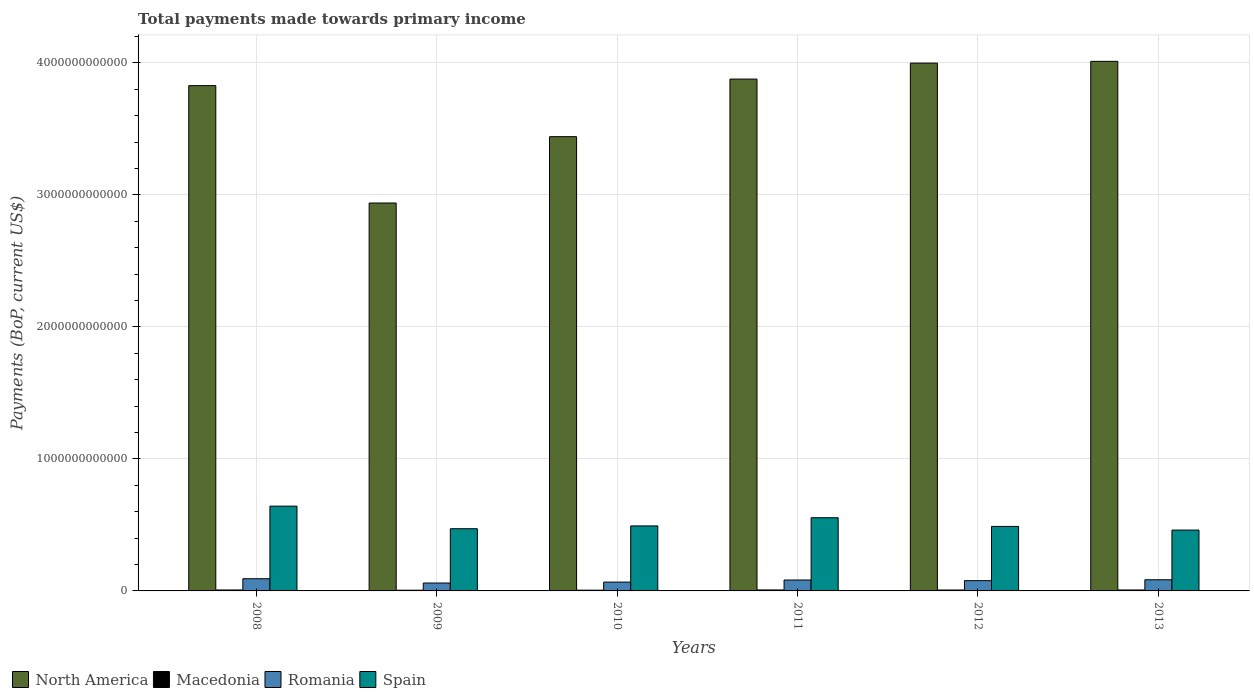How many different coloured bars are there?
Your answer should be very brief. 4. Are the number of bars per tick equal to the number of legend labels?
Offer a terse response. Yes. What is the label of the 3rd group of bars from the left?
Offer a terse response. 2010. In how many cases, is the number of bars for a given year not equal to the number of legend labels?
Make the answer very short. 0. What is the total payments made towards primary income in Spain in 2012?
Ensure brevity in your answer.  4.89e+11. Across all years, what is the maximum total payments made towards primary income in Spain?
Provide a short and direct response. 6.42e+11. Across all years, what is the minimum total payments made towards primary income in Macedonia?
Offer a very short reply. 5.38e+09. In which year was the total payments made towards primary income in Romania maximum?
Provide a succinct answer. 2008. In which year was the total payments made towards primary income in North America minimum?
Give a very brief answer. 2009. What is the total total payments made towards primary income in Romania in the graph?
Provide a short and direct response. 4.64e+11. What is the difference between the total payments made towards primary income in North America in 2009 and that in 2010?
Make the answer very short. -5.02e+11. What is the difference between the total payments made towards primary income in Macedonia in 2011 and the total payments made towards primary income in Spain in 2013?
Your answer should be compact. -4.54e+11. What is the average total payments made towards primary income in North America per year?
Provide a succinct answer. 3.68e+12. In the year 2013, what is the difference between the total payments made towards primary income in Spain and total payments made towards primary income in Romania?
Provide a succinct answer. 3.76e+11. What is the ratio of the total payments made towards primary income in North America in 2008 to that in 2009?
Your answer should be very brief. 1.3. What is the difference between the highest and the second highest total payments made towards primary income in Romania?
Your response must be concise. 7.71e+09. What is the difference between the highest and the lowest total payments made towards primary income in Macedonia?
Provide a short and direct response. 1.97e+09. Is the sum of the total payments made towards primary income in Spain in 2009 and 2013 greater than the maximum total payments made towards primary income in Macedonia across all years?
Offer a terse response. Yes. Is it the case that in every year, the sum of the total payments made towards primary income in Macedonia and total payments made towards primary income in Romania is greater than the sum of total payments made towards primary income in Spain and total payments made towards primary income in North America?
Provide a succinct answer. No. What does the 3rd bar from the left in 2010 represents?
Offer a very short reply. Romania. What does the 3rd bar from the right in 2010 represents?
Provide a succinct answer. Macedonia. Is it the case that in every year, the sum of the total payments made towards primary income in Macedonia and total payments made towards primary income in North America is greater than the total payments made towards primary income in Spain?
Provide a short and direct response. Yes. Are all the bars in the graph horizontal?
Give a very brief answer. No. How many years are there in the graph?
Offer a terse response. 6. What is the difference between two consecutive major ticks on the Y-axis?
Your answer should be very brief. 1.00e+12. Are the values on the major ticks of Y-axis written in scientific E-notation?
Give a very brief answer. No. Does the graph contain grids?
Your response must be concise. Yes. Where does the legend appear in the graph?
Ensure brevity in your answer.  Bottom left. What is the title of the graph?
Your response must be concise. Total payments made towards primary income. What is the label or title of the Y-axis?
Keep it short and to the point. Payments (BoP, current US$). What is the Payments (BoP, current US$) in North America in 2008?
Provide a short and direct response. 3.83e+12. What is the Payments (BoP, current US$) of Macedonia in 2008?
Keep it short and to the point. 7.21e+09. What is the Payments (BoP, current US$) in Romania in 2008?
Your answer should be compact. 9.23e+1. What is the Payments (BoP, current US$) in Spain in 2008?
Give a very brief answer. 6.42e+11. What is the Payments (BoP, current US$) in North America in 2009?
Make the answer very short. 2.94e+12. What is the Payments (BoP, current US$) in Macedonia in 2009?
Offer a terse response. 5.38e+09. What is the Payments (BoP, current US$) in Romania in 2009?
Offer a very short reply. 5.98e+1. What is the Payments (BoP, current US$) in Spain in 2009?
Give a very brief answer. 4.71e+11. What is the Payments (BoP, current US$) in North America in 2010?
Make the answer very short. 3.44e+12. What is the Payments (BoP, current US$) in Macedonia in 2010?
Offer a terse response. 5.79e+09. What is the Payments (BoP, current US$) in Romania in 2010?
Ensure brevity in your answer.  6.70e+1. What is the Payments (BoP, current US$) of Spain in 2010?
Your answer should be very brief. 4.93e+11. What is the Payments (BoP, current US$) in North America in 2011?
Ensure brevity in your answer.  3.88e+12. What is the Payments (BoP, current US$) of Macedonia in 2011?
Your answer should be very brief. 7.35e+09. What is the Payments (BoP, current US$) in Romania in 2011?
Make the answer very short. 8.27e+1. What is the Payments (BoP, current US$) in Spain in 2011?
Give a very brief answer. 5.54e+11. What is the Payments (BoP, current US$) of North America in 2012?
Give a very brief answer. 4.00e+12. What is the Payments (BoP, current US$) in Macedonia in 2012?
Provide a short and direct response. 6.92e+09. What is the Payments (BoP, current US$) of Romania in 2012?
Provide a succinct answer. 7.77e+1. What is the Payments (BoP, current US$) in Spain in 2012?
Your answer should be very brief. 4.89e+11. What is the Payments (BoP, current US$) in North America in 2013?
Provide a succinct answer. 4.01e+12. What is the Payments (BoP, current US$) of Macedonia in 2013?
Provide a short and direct response. 7.11e+09. What is the Payments (BoP, current US$) in Romania in 2013?
Provide a short and direct response. 8.46e+1. What is the Payments (BoP, current US$) of Spain in 2013?
Your answer should be very brief. 4.61e+11. Across all years, what is the maximum Payments (BoP, current US$) in North America?
Provide a succinct answer. 4.01e+12. Across all years, what is the maximum Payments (BoP, current US$) in Macedonia?
Make the answer very short. 7.35e+09. Across all years, what is the maximum Payments (BoP, current US$) of Romania?
Make the answer very short. 9.23e+1. Across all years, what is the maximum Payments (BoP, current US$) in Spain?
Provide a succinct answer. 6.42e+11. Across all years, what is the minimum Payments (BoP, current US$) of North America?
Your response must be concise. 2.94e+12. Across all years, what is the minimum Payments (BoP, current US$) in Macedonia?
Ensure brevity in your answer.  5.38e+09. Across all years, what is the minimum Payments (BoP, current US$) in Romania?
Your response must be concise. 5.98e+1. Across all years, what is the minimum Payments (BoP, current US$) of Spain?
Give a very brief answer. 4.61e+11. What is the total Payments (BoP, current US$) in North America in the graph?
Offer a very short reply. 2.21e+13. What is the total Payments (BoP, current US$) in Macedonia in the graph?
Offer a very short reply. 3.97e+1. What is the total Payments (BoP, current US$) in Romania in the graph?
Ensure brevity in your answer.  4.64e+11. What is the total Payments (BoP, current US$) in Spain in the graph?
Provide a succinct answer. 3.11e+12. What is the difference between the Payments (BoP, current US$) in North America in 2008 and that in 2009?
Keep it short and to the point. 8.89e+11. What is the difference between the Payments (BoP, current US$) in Macedonia in 2008 and that in 2009?
Give a very brief answer. 1.83e+09. What is the difference between the Payments (BoP, current US$) of Romania in 2008 and that in 2009?
Offer a very short reply. 3.25e+1. What is the difference between the Payments (BoP, current US$) of Spain in 2008 and that in 2009?
Offer a very short reply. 1.71e+11. What is the difference between the Payments (BoP, current US$) of North America in 2008 and that in 2010?
Ensure brevity in your answer.  3.87e+11. What is the difference between the Payments (BoP, current US$) in Macedonia in 2008 and that in 2010?
Keep it short and to the point. 1.42e+09. What is the difference between the Payments (BoP, current US$) of Romania in 2008 and that in 2010?
Offer a terse response. 2.54e+1. What is the difference between the Payments (BoP, current US$) of Spain in 2008 and that in 2010?
Ensure brevity in your answer.  1.50e+11. What is the difference between the Payments (BoP, current US$) in North America in 2008 and that in 2011?
Ensure brevity in your answer.  -4.97e+1. What is the difference between the Payments (BoP, current US$) in Macedonia in 2008 and that in 2011?
Your response must be concise. -1.41e+08. What is the difference between the Payments (BoP, current US$) of Romania in 2008 and that in 2011?
Your response must be concise. 9.68e+09. What is the difference between the Payments (BoP, current US$) in Spain in 2008 and that in 2011?
Provide a short and direct response. 8.79e+1. What is the difference between the Payments (BoP, current US$) in North America in 2008 and that in 2012?
Offer a very short reply. -1.71e+11. What is the difference between the Payments (BoP, current US$) of Macedonia in 2008 and that in 2012?
Offer a terse response. 2.89e+08. What is the difference between the Payments (BoP, current US$) in Romania in 2008 and that in 2012?
Give a very brief answer. 1.47e+1. What is the difference between the Payments (BoP, current US$) of Spain in 2008 and that in 2012?
Your response must be concise. 1.54e+11. What is the difference between the Payments (BoP, current US$) of North America in 2008 and that in 2013?
Your answer should be compact. -1.84e+11. What is the difference between the Payments (BoP, current US$) of Macedonia in 2008 and that in 2013?
Offer a terse response. 9.44e+07. What is the difference between the Payments (BoP, current US$) in Romania in 2008 and that in 2013?
Keep it short and to the point. 7.71e+09. What is the difference between the Payments (BoP, current US$) of Spain in 2008 and that in 2013?
Offer a very short reply. 1.81e+11. What is the difference between the Payments (BoP, current US$) in North America in 2009 and that in 2010?
Ensure brevity in your answer.  -5.02e+11. What is the difference between the Payments (BoP, current US$) in Macedonia in 2009 and that in 2010?
Make the answer very short. -4.10e+08. What is the difference between the Payments (BoP, current US$) of Romania in 2009 and that in 2010?
Provide a succinct answer. -7.15e+09. What is the difference between the Payments (BoP, current US$) of Spain in 2009 and that in 2010?
Offer a very short reply. -2.13e+1. What is the difference between the Payments (BoP, current US$) of North America in 2009 and that in 2011?
Keep it short and to the point. -9.39e+11. What is the difference between the Payments (BoP, current US$) of Macedonia in 2009 and that in 2011?
Your response must be concise. -1.97e+09. What is the difference between the Payments (BoP, current US$) of Romania in 2009 and that in 2011?
Your answer should be compact. -2.29e+1. What is the difference between the Payments (BoP, current US$) in Spain in 2009 and that in 2011?
Your answer should be very brief. -8.31e+1. What is the difference between the Payments (BoP, current US$) of North America in 2009 and that in 2012?
Your response must be concise. -1.06e+12. What is the difference between the Payments (BoP, current US$) of Macedonia in 2009 and that in 2012?
Give a very brief answer. -1.54e+09. What is the difference between the Payments (BoP, current US$) of Romania in 2009 and that in 2012?
Ensure brevity in your answer.  -1.79e+1. What is the difference between the Payments (BoP, current US$) of Spain in 2009 and that in 2012?
Offer a very short reply. -1.75e+1. What is the difference between the Payments (BoP, current US$) in North America in 2009 and that in 2013?
Your answer should be compact. -1.07e+12. What is the difference between the Payments (BoP, current US$) of Macedonia in 2009 and that in 2013?
Offer a very short reply. -1.73e+09. What is the difference between the Payments (BoP, current US$) in Romania in 2009 and that in 2013?
Provide a succinct answer. -2.48e+1. What is the difference between the Payments (BoP, current US$) of Spain in 2009 and that in 2013?
Offer a very short reply. 1.04e+1. What is the difference between the Payments (BoP, current US$) of North America in 2010 and that in 2011?
Offer a terse response. -4.37e+11. What is the difference between the Payments (BoP, current US$) of Macedonia in 2010 and that in 2011?
Your answer should be very brief. -1.56e+09. What is the difference between the Payments (BoP, current US$) in Romania in 2010 and that in 2011?
Your response must be concise. -1.57e+1. What is the difference between the Payments (BoP, current US$) in Spain in 2010 and that in 2011?
Keep it short and to the point. -6.18e+1. What is the difference between the Payments (BoP, current US$) in North America in 2010 and that in 2012?
Ensure brevity in your answer.  -5.57e+11. What is the difference between the Payments (BoP, current US$) in Macedonia in 2010 and that in 2012?
Provide a succinct answer. -1.13e+09. What is the difference between the Payments (BoP, current US$) of Romania in 2010 and that in 2012?
Your answer should be compact. -1.07e+1. What is the difference between the Payments (BoP, current US$) in Spain in 2010 and that in 2012?
Your response must be concise. 3.82e+09. What is the difference between the Payments (BoP, current US$) of North America in 2010 and that in 2013?
Provide a succinct answer. -5.71e+11. What is the difference between the Payments (BoP, current US$) of Macedonia in 2010 and that in 2013?
Make the answer very short. -1.32e+09. What is the difference between the Payments (BoP, current US$) of Romania in 2010 and that in 2013?
Provide a succinct answer. -1.77e+1. What is the difference between the Payments (BoP, current US$) in Spain in 2010 and that in 2013?
Your answer should be compact. 3.17e+1. What is the difference between the Payments (BoP, current US$) of North America in 2011 and that in 2012?
Offer a terse response. -1.21e+11. What is the difference between the Payments (BoP, current US$) in Macedonia in 2011 and that in 2012?
Offer a very short reply. 4.29e+08. What is the difference between the Payments (BoP, current US$) in Romania in 2011 and that in 2012?
Offer a very short reply. 4.99e+09. What is the difference between the Payments (BoP, current US$) in Spain in 2011 and that in 2012?
Your answer should be compact. 6.56e+1. What is the difference between the Payments (BoP, current US$) of North America in 2011 and that in 2013?
Offer a terse response. -1.34e+11. What is the difference between the Payments (BoP, current US$) in Macedonia in 2011 and that in 2013?
Give a very brief answer. 2.35e+08. What is the difference between the Payments (BoP, current US$) of Romania in 2011 and that in 2013?
Offer a terse response. -1.97e+09. What is the difference between the Payments (BoP, current US$) of Spain in 2011 and that in 2013?
Give a very brief answer. 9.35e+1. What is the difference between the Payments (BoP, current US$) of North America in 2012 and that in 2013?
Provide a succinct answer. -1.33e+1. What is the difference between the Payments (BoP, current US$) in Macedonia in 2012 and that in 2013?
Keep it short and to the point. -1.94e+08. What is the difference between the Payments (BoP, current US$) of Romania in 2012 and that in 2013?
Provide a succinct answer. -6.96e+09. What is the difference between the Payments (BoP, current US$) of Spain in 2012 and that in 2013?
Keep it short and to the point. 2.79e+1. What is the difference between the Payments (BoP, current US$) of North America in 2008 and the Payments (BoP, current US$) of Macedonia in 2009?
Provide a succinct answer. 3.82e+12. What is the difference between the Payments (BoP, current US$) of North America in 2008 and the Payments (BoP, current US$) of Romania in 2009?
Offer a very short reply. 3.77e+12. What is the difference between the Payments (BoP, current US$) of North America in 2008 and the Payments (BoP, current US$) of Spain in 2009?
Keep it short and to the point. 3.36e+12. What is the difference between the Payments (BoP, current US$) of Macedonia in 2008 and the Payments (BoP, current US$) of Romania in 2009?
Give a very brief answer. -5.26e+1. What is the difference between the Payments (BoP, current US$) in Macedonia in 2008 and the Payments (BoP, current US$) in Spain in 2009?
Offer a very short reply. -4.64e+11. What is the difference between the Payments (BoP, current US$) in Romania in 2008 and the Payments (BoP, current US$) in Spain in 2009?
Your answer should be very brief. -3.79e+11. What is the difference between the Payments (BoP, current US$) in North America in 2008 and the Payments (BoP, current US$) in Macedonia in 2010?
Provide a short and direct response. 3.82e+12. What is the difference between the Payments (BoP, current US$) in North America in 2008 and the Payments (BoP, current US$) in Romania in 2010?
Your answer should be very brief. 3.76e+12. What is the difference between the Payments (BoP, current US$) of North America in 2008 and the Payments (BoP, current US$) of Spain in 2010?
Offer a terse response. 3.34e+12. What is the difference between the Payments (BoP, current US$) in Macedonia in 2008 and the Payments (BoP, current US$) in Romania in 2010?
Make the answer very short. -5.98e+1. What is the difference between the Payments (BoP, current US$) of Macedonia in 2008 and the Payments (BoP, current US$) of Spain in 2010?
Keep it short and to the point. -4.85e+11. What is the difference between the Payments (BoP, current US$) of Romania in 2008 and the Payments (BoP, current US$) of Spain in 2010?
Your answer should be very brief. -4.00e+11. What is the difference between the Payments (BoP, current US$) of North America in 2008 and the Payments (BoP, current US$) of Macedonia in 2011?
Provide a short and direct response. 3.82e+12. What is the difference between the Payments (BoP, current US$) of North America in 2008 and the Payments (BoP, current US$) of Romania in 2011?
Make the answer very short. 3.75e+12. What is the difference between the Payments (BoP, current US$) of North America in 2008 and the Payments (BoP, current US$) of Spain in 2011?
Make the answer very short. 3.27e+12. What is the difference between the Payments (BoP, current US$) of Macedonia in 2008 and the Payments (BoP, current US$) of Romania in 2011?
Ensure brevity in your answer.  -7.55e+1. What is the difference between the Payments (BoP, current US$) of Macedonia in 2008 and the Payments (BoP, current US$) of Spain in 2011?
Make the answer very short. -5.47e+11. What is the difference between the Payments (BoP, current US$) in Romania in 2008 and the Payments (BoP, current US$) in Spain in 2011?
Make the answer very short. -4.62e+11. What is the difference between the Payments (BoP, current US$) of North America in 2008 and the Payments (BoP, current US$) of Macedonia in 2012?
Offer a terse response. 3.82e+12. What is the difference between the Payments (BoP, current US$) in North America in 2008 and the Payments (BoP, current US$) in Romania in 2012?
Your answer should be very brief. 3.75e+12. What is the difference between the Payments (BoP, current US$) of North America in 2008 and the Payments (BoP, current US$) of Spain in 2012?
Keep it short and to the point. 3.34e+12. What is the difference between the Payments (BoP, current US$) in Macedonia in 2008 and the Payments (BoP, current US$) in Romania in 2012?
Your answer should be compact. -7.05e+1. What is the difference between the Payments (BoP, current US$) in Macedonia in 2008 and the Payments (BoP, current US$) in Spain in 2012?
Give a very brief answer. -4.82e+11. What is the difference between the Payments (BoP, current US$) in Romania in 2008 and the Payments (BoP, current US$) in Spain in 2012?
Offer a very short reply. -3.96e+11. What is the difference between the Payments (BoP, current US$) of North America in 2008 and the Payments (BoP, current US$) of Macedonia in 2013?
Provide a short and direct response. 3.82e+12. What is the difference between the Payments (BoP, current US$) of North America in 2008 and the Payments (BoP, current US$) of Romania in 2013?
Provide a succinct answer. 3.74e+12. What is the difference between the Payments (BoP, current US$) in North America in 2008 and the Payments (BoP, current US$) in Spain in 2013?
Provide a succinct answer. 3.37e+12. What is the difference between the Payments (BoP, current US$) in Macedonia in 2008 and the Payments (BoP, current US$) in Romania in 2013?
Keep it short and to the point. -7.74e+1. What is the difference between the Payments (BoP, current US$) in Macedonia in 2008 and the Payments (BoP, current US$) in Spain in 2013?
Make the answer very short. -4.54e+11. What is the difference between the Payments (BoP, current US$) of Romania in 2008 and the Payments (BoP, current US$) of Spain in 2013?
Offer a terse response. -3.69e+11. What is the difference between the Payments (BoP, current US$) in North America in 2009 and the Payments (BoP, current US$) in Macedonia in 2010?
Make the answer very short. 2.93e+12. What is the difference between the Payments (BoP, current US$) in North America in 2009 and the Payments (BoP, current US$) in Romania in 2010?
Your answer should be very brief. 2.87e+12. What is the difference between the Payments (BoP, current US$) in North America in 2009 and the Payments (BoP, current US$) in Spain in 2010?
Your response must be concise. 2.45e+12. What is the difference between the Payments (BoP, current US$) in Macedonia in 2009 and the Payments (BoP, current US$) in Romania in 2010?
Keep it short and to the point. -6.16e+1. What is the difference between the Payments (BoP, current US$) of Macedonia in 2009 and the Payments (BoP, current US$) of Spain in 2010?
Your response must be concise. -4.87e+11. What is the difference between the Payments (BoP, current US$) of Romania in 2009 and the Payments (BoP, current US$) of Spain in 2010?
Ensure brevity in your answer.  -4.33e+11. What is the difference between the Payments (BoP, current US$) in North America in 2009 and the Payments (BoP, current US$) in Macedonia in 2011?
Ensure brevity in your answer.  2.93e+12. What is the difference between the Payments (BoP, current US$) in North America in 2009 and the Payments (BoP, current US$) in Romania in 2011?
Ensure brevity in your answer.  2.86e+12. What is the difference between the Payments (BoP, current US$) in North America in 2009 and the Payments (BoP, current US$) in Spain in 2011?
Your answer should be compact. 2.38e+12. What is the difference between the Payments (BoP, current US$) in Macedonia in 2009 and the Payments (BoP, current US$) in Romania in 2011?
Make the answer very short. -7.73e+1. What is the difference between the Payments (BoP, current US$) in Macedonia in 2009 and the Payments (BoP, current US$) in Spain in 2011?
Make the answer very short. -5.49e+11. What is the difference between the Payments (BoP, current US$) of Romania in 2009 and the Payments (BoP, current US$) of Spain in 2011?
Give a very brief answer. -4.95e+11. What is the difference between the Payments (BoP, current US$) of North America in 2009 and the Payments (BoP, current US$) of Macedonia in 2012?
Provide a short and direct response. 2.93e+12. What is the difference between the Payments (BoP, current US$) in North America in 2009 and the Payments (BoP, current US$) in Romania in 2012?
Ensure brevity in your answer.  2.86e+12. What is the difference between the Payments (BoP, current US$) of North America in 2009 and the Payments (BoP, current US$) of Spain in 2012?
Your response must be concise. 2.45e+12. What is the difference between the Payments (BoP, current US$) of Macedonia in 2009 and the Payments (BoP, current US$) of Romania in 2012?
Your response must be concise. -7.23e+1. What is the difference between the Payments (BoP, current US$) in Macedonia in 2009 and the Payments (BoP, current US$) in Spain in 2012?
Provide a succinct answer. -4.83e+11. What is the difference between the Payments (BoP, current US$) in Romania in 2009 and the Payments (BoP, current US$) in Spain in 2012?
Your response must be concise. -4.29e+11. What is the difference between the Payments (BoP, current US$) of North America in 2009 and the Payments (BoP, current US$) of Macedonia in 2013?
Make the answer very short. 2.93e+12. What is the difference between the Payments (BoP, current US$) of North America in 2009 and the Payments (BoP, current US$) of Romania in 2013?
Your answer should be very brief. 2.85e+12. What is the difference between the Payments (BoP, current US$) of North America in 2009 and the Payments (BoP, current US$) of Spain in 2013?
Make the answer very short. 2.48e+12. What is the difference between the Payments (BoP, current US$) in Macedonia in 2009 and the Payments (BoP, current US$) in Romania in 2013?
Make the answer very short. -7.93e+1. What is the difference between the Payments (BoP, current US$) in Macedonia in 2009 and the Payments (BoP, current US$) in Spain in 2013?
Make the answer very short. -4.56e+11. What is the difference between the Payments (BoP, current US$) in Romania in 2009 and the Payments (BoP, current US$) in Spain in 2013?
Provide a succinct answer. -4.01e+11. What is the difference between the Payments (BoP, current US$) of North America in 2010 and the Payments (BoP, current US$) of Macedonia in 2011?
Make the answer very short. 3.43e+12. What is the difference between the Payments (BoP, current US$) in North America in 2010 and the Payments (BoP, current US$) in Romania in 2011?
Your answer should be compact. 3.36e+12. What is the difference between the Payments (BoP, current US$) in North America in 2010 and the Payments (BoP, current US$) in Spain in 2011?
Ensure brevity in your answer.  2.89e+12. What is the difference between the Payments (BoP, current US$) in Macedonia in 2010 and the Payments (BoP, current US$) in Romania in 2011?
Your response must be concise. -7.69e+1. What is the difference between the Payments (BoP, current US$) in Macedonia in 2010 and the Payments (BoP, current US$) in Spain in 2011?
Your answer should be very brief. -5.49e+11. What is the difference between the Payments (BoP, current US$) of Romania in 2010 and the Payments (BoP, current US$) of Spain in 2011?
Provide a short and direct response. -4.87e+11. What is the difference between the Payments (BoP, current US$) of North America in 2010 and the Payments (BoP, current US$) of Macedonia in 2012?
Your answer should be very brief. 3.43e+12. What is the difference between the Payments (BoP, current US$) in North America in 2010 and the Payments (BoP, current US$) in Romania in 2012?
Offer a very short reply. 3.36e+12. What is the difference between the Payments (BoP, current US$) of North America in 2010 and the Payments (BoP, current US$) of Spain in 2012?
Make the answer very short. 2.95e+12. What is the difference between the Payments (BoP, current US$) in Macedonia in 2010 and the Payments (BoP, current US$) in Romania in 2012?
Your response must be concise. -7.19e+1. What is the difference between the Payments (BoP, current US$) of Macedonia in 2010 and the Payments (BoP, current US$) of Spain in 2012?
Make the answer very short. -4.83e+11. What is the difference between the Payments (BoP, current US$) in Romania in 2010 and the Payments (BoP, current US$) in Spain in 2012?
Ensure brevity in your answer.  -4.22e+11. What is the difference between the Payments (BoP, current US$) in North America in 2010 and the Payments (BoP, current US$) in Macedonia in 2013?
Offer a very short reply. 3.43e+12. What is the difference between the Payments (BoP, current US$) in North America in 2010 and the Payments (BoP, current US$) in Romania in 2013?
Your answer should be compact. 3.36e+12. What is the difference between the Payments (BoP, current US$) in North America in 2010 and the Payments (BoP, current US$) in Spain in 2013?
Offer a very short reply. 2.98e+12. What is the difference between the Payments (BoP, current US$) in Macedonia in 2010 and the Payments (BoP, current US$) in Romania in 2013?
Offer a terse response. -7.88e+1. What is the difference between the Payments (BoP, current US$) in Macedonia in 2010 and the Payments (BoP, current US$) in Spain in 2013?
Provide a succinct answer. -4.55e+11. What is the difference between the Payments (BoP, current US$) of Romania in 2010 and the Payments (BoP, current US$) of Spain in 2013?
Keep it short and to the point. -3.94e+11. What is the difference between the Payments (BoP, current US$) in North America in 2011 and the Payments (BoP, current US$) in Macedonia in 2012?
Provide a succinct answer. 3.87e+12. What is the difference between the Payments (BoP, current US$) in North America in 2011 and the Payments (BoP, current US$) in Romania in 2012?
Offer a terse response. 3.80e+12. What is the difference between the Payments (BoP, current US$) in North America in 2011 and the Payments (BoP, current US$) in Spain in 2012?
Give a very brief answer. 3.39e+12. What is the difference between the Payments (BoP, current US$) of Macedonia in 2011 and the Payments (BoP, current US$) of Romania in 2012?
Offer a very short reply. -7.03e+1. What is the difference between the Payments (BoP, current US$) in Macedonia in 2011 and the Payments (BoP, current US$) in Spain in 2012?
Your answer should be compact. -4.81e+11. What is the difference between the Payments (BoP, current US$) in Romania in 2011 and the Payments (BoP, current US$) in Spain in 2012?
Provide a succinct answer. -4.06e+11. What is the difference between the Payments (BoP, current US$) of North America in 2011 and the Payments (BoP, current US$) of Macedonia in 2013?
Your answer should be compact. 3.87e+12. What is the difference between the Payments (BoP, current US$) in North America in 2011 and the Payments (BoP, current US$) in Romania in 2013?
Provide a short and direct response. 3.79e+12. What is the difference between the Payments (BoP, current US$) in North America in 2011 and the Payments (BoP, current US$) in Spain in 2013?
Your answer should be very brief. 3.42e+12. What is the difference between the Payments (BoP, current US$) of Macedonia in 2011 and the Payments (BoP, current US$) of Romania in 2013?
Ensure brevity in your answer.  -7.73e+1. What is the difference between the Payments (BoP, current US$) in Macedonia in 2011 and the Payments (BoP, current US$) in Spain in 2013?
Give a very brief answer. -4.54e+11. What is the difference between the Payments (BoP, current US$) in Romania in 2011 and the Payments (BoP, current US$) in Spain in 2013?
Give a very brief answer. -3.78e+11. What is the difference between the Payments (BoP, current US$) in North America in 2012 and the Payments (BoP, current US$) in Macedonia in 2013?
Your answer should be compact. 3.99e+12. What is the difference between the Payments (BoP, current US$) in North America in 2012 and the Payments (BoP, current US$) in Romania in 2013?
Keep it short and to the point. 3.91e+12. What is the difference between the Payments (BoP, current US$) in North America in 2012 and the Payments (BoP, current US$) in Spain in 2013?
Your response must be concise. 3.54e+12. What is the difference between the Payments (BoP, current US$) of Macedonia in 2012 and the Payments (BoP, current US$) of Romania in 2013?
Give a very brief answer. -7.77e+1. What is the difference between the Payments (BoP, current US$) in Macedonia in 2012 and the Payments (BoP, current US$) in Spain in 2013?
Offer a very short reply. -4.54e+11. What is the difference between the Payments (BoP, current US$) in Romania in 2012 and the Payments (BoP, current US$) in Spain in 2013?
Your answer should be compact. -3.83e+11. What is the average Payments (BoP, current US$) of North America per year?
Give a very brief answer. 3.68e+12. What is the average Payments (BoP, current US$) of Macedonia per year?
Make the answer very short. 6.62e+09. What is the average Payments (BoP, current US$) of Romania per year?
Your response must be concise. 7.74e+1. What is the average Payments (BoP, current US$) of Spain per year?
Your answer should be very brief. 5.18e+11. In the year 2008, what is the difference between the Payments (BoP, current US$) in North America and Payments (BoP, current US$) in Macedonia?
Offer a terse response. 3.82e+12. In the year 2008, what is the difference between the Payments (BoP, current US$) in North America and Payments (BoP, current US$) in Romania?
Offer a terse response. 3.74e+12. In the year 2008, what is the difference between the Payments (BoP, current US$) in North America and Payments (BoP, current US$) in Spain?
Provide a short and direct response. 3.19e+12. In the year 2008, what is the difference between the Payments (BoP, current US$) in Macedonia and Payments (BoP, current US$) in Romania?
Make the answer very short. -8.51e+1. In the year 2008, what is the difference between the Payments (BoP, current US$) in Macedonia and Payments (BoP, current US$) in Spain?
Offer a very short reply. -6.35e+11. In the year 2008, what is the difference between the Payments (BoP, current US$) of Romania and Payments (BoP, current US$) of Spain?
Offer a terse response. -5.50e+11. In the year 2009, what is the difference between the Payments (BoP, current US$) of North America and Payments (BoP, current US$) of Macedonia?
Keep it short and to the point. 2.93e+12. In the year 2009, what is the difference between the Payments (BoP, current US$) in North America and Payments (BoP, current US$) in Romania?
Offer a terse response. 2.88e+12. In the year 2009, what is the difference between the Payments (BoP, current US$) of North America and Payments (BoP, current US$) of Spain?
Make the answer very short. 2.47e+12. In the year 2009, what is the difference between the Payments (BoP, current US$) in Macedonia and Payments (BoP, current US$) in Romania?
Ensure brevity in your answer.  -5.44e+1. In the year 2009, what is the difference between the Payments (BoP, current US$) of Macedonia and Payments (BoP, current US$) of Spain?
Provide a short and direct response. -4.66e+11. In the year 2009, what is the difference between the Payments (BoP, current US$) of Romania and Payments (BoP, current US$) of Spain?
Give a very brief answer. -4.11e+11. In the year 2010, what is the difference between the Payments (BoP, current US$) of North America and Payments (BoP, current US$) of Macedonia?
Offer a very short reply. 3.44e+12. In the year 2010, what is the difference between the Payments (BoP, current US$) in North America and Payments (BoP, current US$) in Romania?
Your answer should be compact. 3.37e+12. In the year 2010, what is the difference between the Payments (BoP, current US$) of North America and Payments (BoP, current US$) of Spain?
Your answer should be very brief. 2.95e+12. In the year 2010, what is the difference between the Payments (BoP, current US$) in Macedonia and Payments (BoP, current US$) in Romania?
Your response must be concise. -6.12e+1. In the year 2010, what is the difference between the Payments (BoP, current US$) in Macedonia and Payments (BoP, current US$) in Spain?
Provide a short and direct response. -4.87e+11. In the year 2010, what is the difference between the Payments (BoP, current US$) in Romania and Payments (BoP, current US$) in Spain?
Your answer should be compact. -4.26e+11. In the year 2011, what is the difference between the Payments (BoP, current US$) of North America and Payments (BoP, current US$) of Macedonia?
Your answer should be compact. 3.87e+12. In the year 2011, what is the difference between the Payments (BoP, current US$) in North America and Payments (BoP, current US$) in Romania?
Offer a very short reply. 3.80e+12. In the year 2011, what is the difference between the Payments (BoP, current US$) in North America and Payments (BoP, current US$) in Spain?
Offer a very short reply. 3.32e+12. In the year 2011, what is the difference between the Payments (BoP, current US$) of Macedonia and Payments (BoP, current US$) of Romania?
Your response must be concise. -7.53e+1. In the year 2011, what is the difference between the Payments (BoP, current US$) in Macedonia and Payments (BoP, current US$) in Spain?
Give a very brief answer. -5.47e+11. In the year 2011, what is the difference between the Payments (BoP, current US$) in Romania and Payments (BoP, current US$) in Spain?
Provide a short and direct response. -4.72e+11. In the year 2012, what is the difference between the Payments (BoP, current US$) in North America and Payments (BoP, current US$) in Macedonia?
Your answer should be very brief. 3.99e+12. In the year 2012, what is the difference between the Payments (BoP, current US$) in North America and Payments (BoP, current US$) in Romania?
Make the answer very short. 3.92e+12. In the year 2012, what is the difference between the Payments (BoP, current US$) of North America and Payments (BoP, current US$) of Spain?
Your answer should be compact. 3.51e+12. In the year 2012, what is the difference between the Payments (BoP, current US$) of Macedonia and Payments (BoP, current US$) of Romania?
Keep it short and to the point. -7.08e+1. In the year 2012, what is the difference between the Payments (BoP, current US$) of Macedonia and Payments (BoP, current US$) of Spain?
Your response must be concise. -4.82e+11. In the year 2012, what is the difference between the Payments (BoP, current US$) in Romania and Payments (BoP, current US$) in Spain?
Offer a terse response. -4.11e+11. In the year 2013, what is the difference between the Payments (BoP, current US$) of North America and Payments (BoP, current US$) of Macedonia?
Provide a succinct answer. 4.01e+12. In the year 2013, what is the difference between the Payments (BoP, current US$) in North America and Payments (BoP, current US$) in Romania?
Provide a short and direct response. 3.93e+12. In the year 2013, what is the difference between the Payments (BoP, current US$) in North America and Payments (BoP, current US$) in Spain?
Ensure brevity in your answer.  3.55e+12. In the year 2013, what is the difference between the Payments (BoP, current US$) in Macedonia and Payments (BoP, current US$) in Romania?
Provide a succinct answer. -7.75e+1. In the year 2013, what is the difference between the Payments (BoP, current US$) of Macedonia and Payments (BoP, current US$) of Spain?
Offer a terse response. -4.54e+11. In the year 2013, what is the difference between the Payments (BoP, current US$) of Romania and Payments (BoP, current US$) of Spain?
Give a very brief answer. -3.76e+11. What is the ratio of the Payments (BoP, current US$) in North America in 2008 to that in 2009?
Give a very brief answer. 1.3. What is the ratio of the Payments (BoP, current US$) of Macedonia in 2008 to that in 2009?
Give a very brief answer. 1.34. What is the ratio of the Payments (BoP, current US$) of Romania in 2008 to that in 2009?
Provide a succinct answer. 1.54. What is the ratio of the Payments (BoP, current US$) of Spain in 2008 to that in 2009?
Your response must be concise. 1.36. What is the ratio of the Payments (BoP, current US$) in North America in 2008 to that in 2010?
Provide a succinct answer. 1.11. What is the ratio of the Payments (BoP, current US$) of Macedonia in 2008 to that in 2010?
Give a very brief answer. 1.24. What is the ratio of the Payments (BoP, current US$) of Romania in 2008 to that in 2010?
Your answer should be very brief. 1.38. What is the ratio of the Payments (BoP, current US$) of Spain in 2008 to that in 2010?
Your response must be concise. 1.3. What is the ratio of the Payments (BoP, current US$) of North America in 2008 to that in 2011?
Your answer should be very brief. 0.99. What is the ratio of the Payments (BoP, current US$) in Macedonia in 2008 to that in 2011?
Your answer should be compact. 0.98. What is the ratio of the Payments (BoP, current US$) of Romania in 2008 to that in 2011?
Offer a terse response. 1.12. What is the ratio of the Payments (BoP, current US$) of Spain in 2008 to that in 2011?
Provide a succinct answer. 1.16. What is the ratio of the Payments (BoP, current US$) of North America in 2008 to that in 2012?
Your answer should be compact. 0.96. What is the ratio of the Payments (BoP, current US$) in Macedonia in 2008 to that in 2012?
Your answer should be compact. 1.04. What is the ratio of the Payments (BoP, current US$) in Romania in 2008 to that in 2012?
Give a very brief answer. 1.19. What is the ratio of the Payments (BoP, current US$) in Spain in 2008 to that in 2012?
Give a very brief answer. 1.31. What is the ratio of the Payments (BoP, current US$) of North America in 2008 to that in 2013?
Offer a terse response. 0.95. What is the ratio of the Payments (BoP, current US$) of Macedonia in 2008 to that in 2013?
Your answer should be very brief. 1.01. What is the ratio of the Payments (BoP, current US$) in Romania in 2008 to that in 2013?
Your response must be concise. 1.09. What is the ratio of the Payments (BoP, current US$) in Spain in 2008 to that in 2013?
Your response must be concise. 1.39. What is the ratio of the Payments (BoP, current US$) of North America in 2009 to that in 2010?
Give a very brief answer. 0.85. What is the ratio of the Payments (BoP, current US$) in Macedonia in 2009 to that in 2010?
Provide a succinct answer. 0.93. What is the ratio of the Payments (BoP, current US$) in Romania in 2009 to that in 2010?
Your answer should be very brief. 0.89. What is the ratio of the Payments (BoP, current US$) of Spain in 2009 to that in 2010?
Ensure brevity in your answer.  0.96. What is the ratio of the Payments (BoP, current US$) of North America in 2009 to that in 2011?
Make the answer very short. 0.76. What is the ratio of the Payments (BoP, current US$) of Macedonia in 2009 to that in 2011?
Your answer should be compact. 0.73. What is the ratio of the Payments (BoP, current US$) in Romania in 2009 to that in 2011?
Provide a short and direct response. 0.72. What is the ratio of the Payments (BoP, current US$) of North America in 2009 to that in 2012?
Provide a succinct answer. 0.73. What is the ratio of the Payments (BoP, current US$) in Macedonia in 2009 to that in 2012?
Ensure brevity in your answer.  0.78. What is the ratio of the Payments (BoP, current US$) of Romania in 2009 to that in 2012?
Ensure brevity in your answer.  0.77. What is the ratio of the Payments (BoP, current US$) in Spain in 2009 to that in 2012?
Offer a very short reply. 0.96. What is the ratio of the Payments (BoP, current US$) in North America in 2009 to that in 2013?
Give a very brief answer. 0.73. What is the ratio of the Payments (BoP, current US$) in Macedonia in 2009 to that in 2013?
Offer a terse response. 0.76. What is the ratio of the Payments (BoP, current US$) of Romania in 2009 to that in 2013?
Offer a terse response. 0.71. What is the ratio of the Payments (BoP, current US$) of Spain in 2009 to that in 2013?
Make the answer very short. 1.02. What is the ratio of the Payments (BoP, current US$) of North America in 2010 to that in 2011?
Offer a terse response. 0.89. What is the ratio of the Payments (BoP, current US$) in Macedonia in 2010 to that in 2011?
Offer a very short reply. 0.79. What is the ratio of the Payments (BoP, current US$) in Romania in 2010 to that in 2011?
Offer a very short reply. 0.81. What is the ratio of the Payments (BoP, current US$) in Spain in 2010 to that in 2011?
Your answer should be compact. 0.89. What is the ratio of the Payments (BoP, current US$) of North America in 2010 to that in 2012?
Give a very brief answer. 0.86. What is the ratio of the Payments (BoP, current US$) in Macedonia in 2010 to that in 2012?
Ensure brevity in your answer.  0.84. What is the ratio of the Payments (BoP, current US$) of Romania in 2010 to that in 2012?
Ensure brevity in your answer.  0.86. What is the ratio of the Payments (BoP, current US$) in Spain in 2010 to that in 2012?
Your answer should be compact. 1.01. What is the ratio of the Payments (BoP, current US$) of North America in 2010 to that in 2013?
Make the answer very short. 0.86. What is the ratio of the Payments (BoP, current US$) in Macedonia in 2010 to that in 2013?
Your answer should be very brief. 0.81. What is the ratio of the Payments (BoP, current US$) in Romania in 2010 to that in 2013?
Ensure brevity in your answer.  0.79. What is the ratio of the Payments (BoP, current US$) in Spain in 2010 to that in 2013?
Your response must be concise. 1.07. What is the ratio of the Payments (BoP, current US$) of North America in 2011 to that in 2012?
Ensure brevity in your answer.  0.97. What is the ratio of the Payments (BoP, current US$) of Macedonia in 2011 to that in 2012?
Your answer should be very brief. 1.06. What is the ratio of the Payments (BoP, current US$) in Romania in 2011 to that in 2012?
Offer a terse response. 1.06. What is the ratio of the Payments (BoP, current US$) of Spain in 2011 to that in 2012?
Offer a very short reply. 1.13. What is the ratio of the Payments (BoP, current US$) of North America in 2011 to that in 2013?
Your response must be concise. 0.97. What is the ratio of the Payments (BoP, current US$) of Macedonia in 2011 to that in 2013?
Your response must be concise. 1.03. What is the ratio of the Payments (BoP, current US$) in Romania in 2011 to that in 2013?
Your answer should be compact. 0.98. What is the ratio of the Payments (BoP, current US$) in Spain in 2011 to that in 2013?
Keep it short and to the point. 1.2. What is the ratio of the Payments (BoP, current US$) in North America in 2012 to that in 2013?
Offer a very short reply. 1. What is the ratio of the Payments (BoP, current US$) of Macedonia in 2012 to that in 2013?
Make the answer very short. 0.97. What is the ratio of the Payments (BoP, current US$) of Romania in 2012 to that in 2013?
Your answer should be compact. 0.92. What is the ratio of the Payments (BoP, current US$) of Spain in 2012 to that in 2013?
Make the answer very short. 1.06. What is the difference between the highest and the second highest Payments (BoP, current US$) in North America?
Ensure brevity in your answer.  1.33e+1. What is the difference between the highest and the second highest Payments (BoP, current US$) of Macedonia?
Offer a very short reply. 1.41e+08. What is the difference between the highest and the second highest Payments (BoP, current US$) in Romania?
Your response must be concise. 7.71e+09. What is the difference between the highest and the second highest Payments (BoP, current US$) of Spain?
Your answer should be very brief. 8.79e+1. What is the difference between the highest and the lowest Payments (BoP, current US$) of North America?
Your answer should be compact. 1.07e+12. What is the difference between the highest and the lowest Payments (BoP, current US$) of Macedonia?
Keep it short and to the point. 1.97e+09. What is the difference between the highest and the lowest Payments (BoP, current US$) in Romania?
Your answer should be compact. 3.25e+1. What is the difference between the highest and the lowest Payments (BoP, current US$) of Spain?
Give a very brief answer. 1.81e+11. 